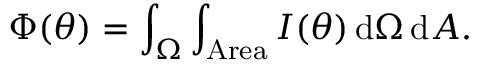Convert formula to latex. <formula><loc_0><loc_0><loc_500><loc_500>\Phi ( \theta ) = \int _ { \Omega } \int _ { A r e a } I ( \theta ) \, d \Omega \, d A .</formula> 